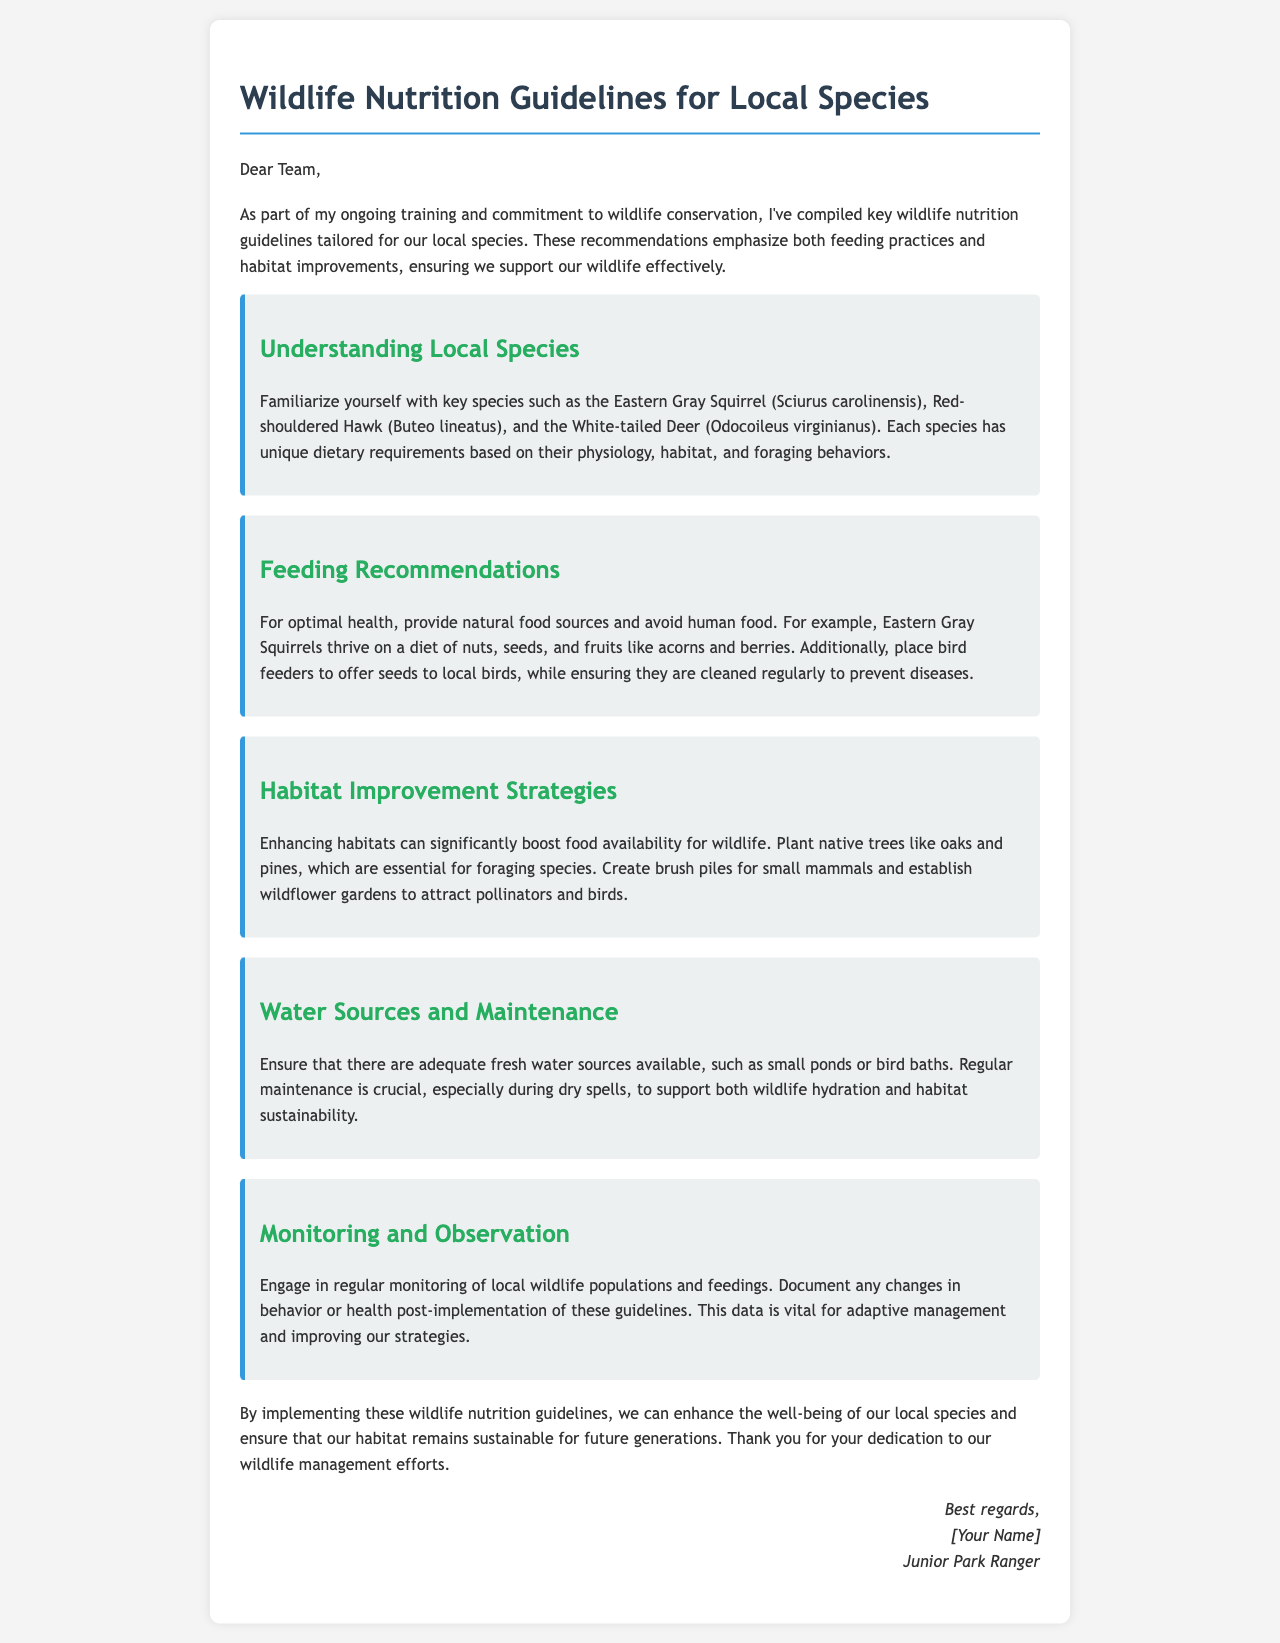What are the three key species mentioned? The document lists the Eastern Gray Squirrel, Red-shouldered Hawk, and White-tailed Deer as key species to understand their dietary needs.
Answer: Eastern Gray Squirrel, Red-shouldered Hawk, White-tailed Deer What is the primary food for Eastern Gray Squirrels? The document states that Eastern Gray Squirrels thrive on a diet of nuts, seeds, and fruits like acorns and berries.
Answer: Nuts, seeds, fruits What should be placed to offer seeds to local birds? The document recommends placing bird feeders to provide seeds for local birds.
Answer: Bird feeders What type of trees should be planted for habitat improvement? According to the guidelines, planting native trees like oaks and pines is essential for enhancing habitats for wildlife.
Answer: Oaks, pines Why is regular maintenance of water sources important? The document highlights that regular maintenance ensures wildlife hydration and habitat sustainability, especially during dry spells.
Answer: Wildlife hydration, habitat sustainability What should be done after implementing feeding guidelines? The document suggests engaging in regular monitoring and documenting any changes in behavior or health post-implementation.
Answer: Regular monitoring 